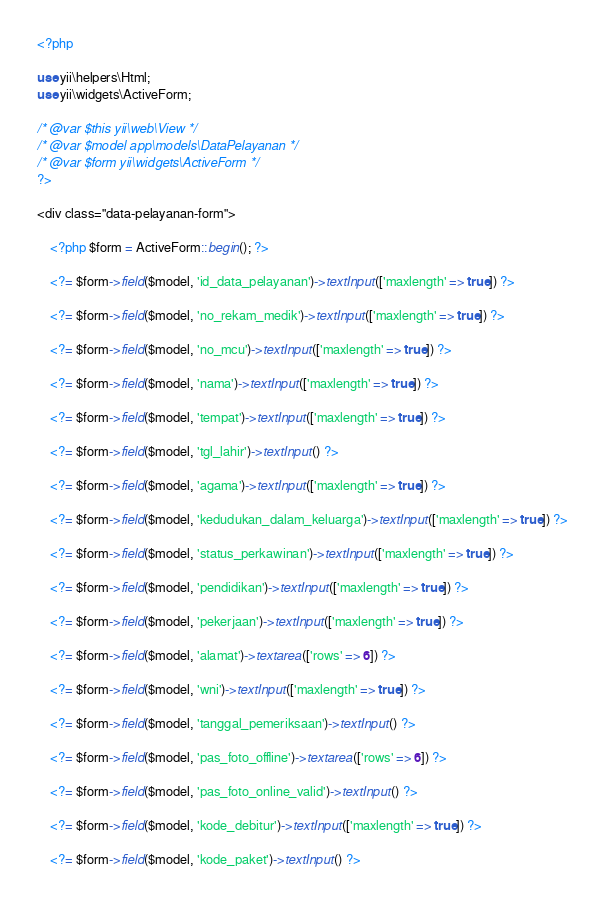<code> <loc_0><loc_0><loc_500><loc_500><_PHP_><?php

use yii\helpers\Html;
use yii\widgets\ActiveForm;

/* @var $this yii\web\View */
/* @var $model app\models\DataPelayanan */
/* @var $form yii\widgets\ActiveForm */
?>

<div class="data-pelayanan-form">

    <?php $form = ActiveForm::begin(); ?>

    <?= $form->field($model, 'id_data_pelayanan')->textInput(['maxlength' => true]) ?>

    <?= $form->field($model, 'no_rekam_medik')->textInput(['maxlength' => true]) ?>

    <?= $form->field($model, 'no_mcu')->textInput(['maxlength' => true]) ?>

    <?= $form->field($model, 'nama')->textInput(['maxlength' => true]) ?>

    <?= $form->field($model, 'tempat')->textInput(['maxlength' => true]) ?>

    <?= $form->field($model, 'tgl_lahir')->textInput() ?>

    <?= $form->field($model, 'agama')->textInput(['maxlength' => true]) ?>

    <?= $form->field($model, 'kedudukan_dalam_keluarga')->textInput(['maxlength' => true]) ?>

    <?= $form->field($model, 'status_perkawinan')->textInput(['maxlength' => true]) ?>

    <?= $form->field($model, 'pendidikan')->textInput(['maxlength' => true]) ?>

    <?= $form->field($model, 'pekerjaan')->textInput(['maxlength' => true]) ?>

    <?= $form->field($model, 'alamat')->textarea(['rows' => 6]) ?>

    <?= $form->field($model, 'wni')->textInput(['maxlength' => true]) ?>

    <?= $form->field($model, 'tanggal_pemeriksaan')->textInput() ?>

    <?= $form->field($model, 'pas_foto_offline')->textarea(['rows' => 6]) ?>

    <?= $form->field($model, 'pas_foto_online_valid')->textInput() ?>

    <?= $form->field($model, 'kode_debitur')->textInput(['maxlength' => true]) ?>

    <?= $form->field($model, 'kode_paket')->textInput() ?>
</code> 